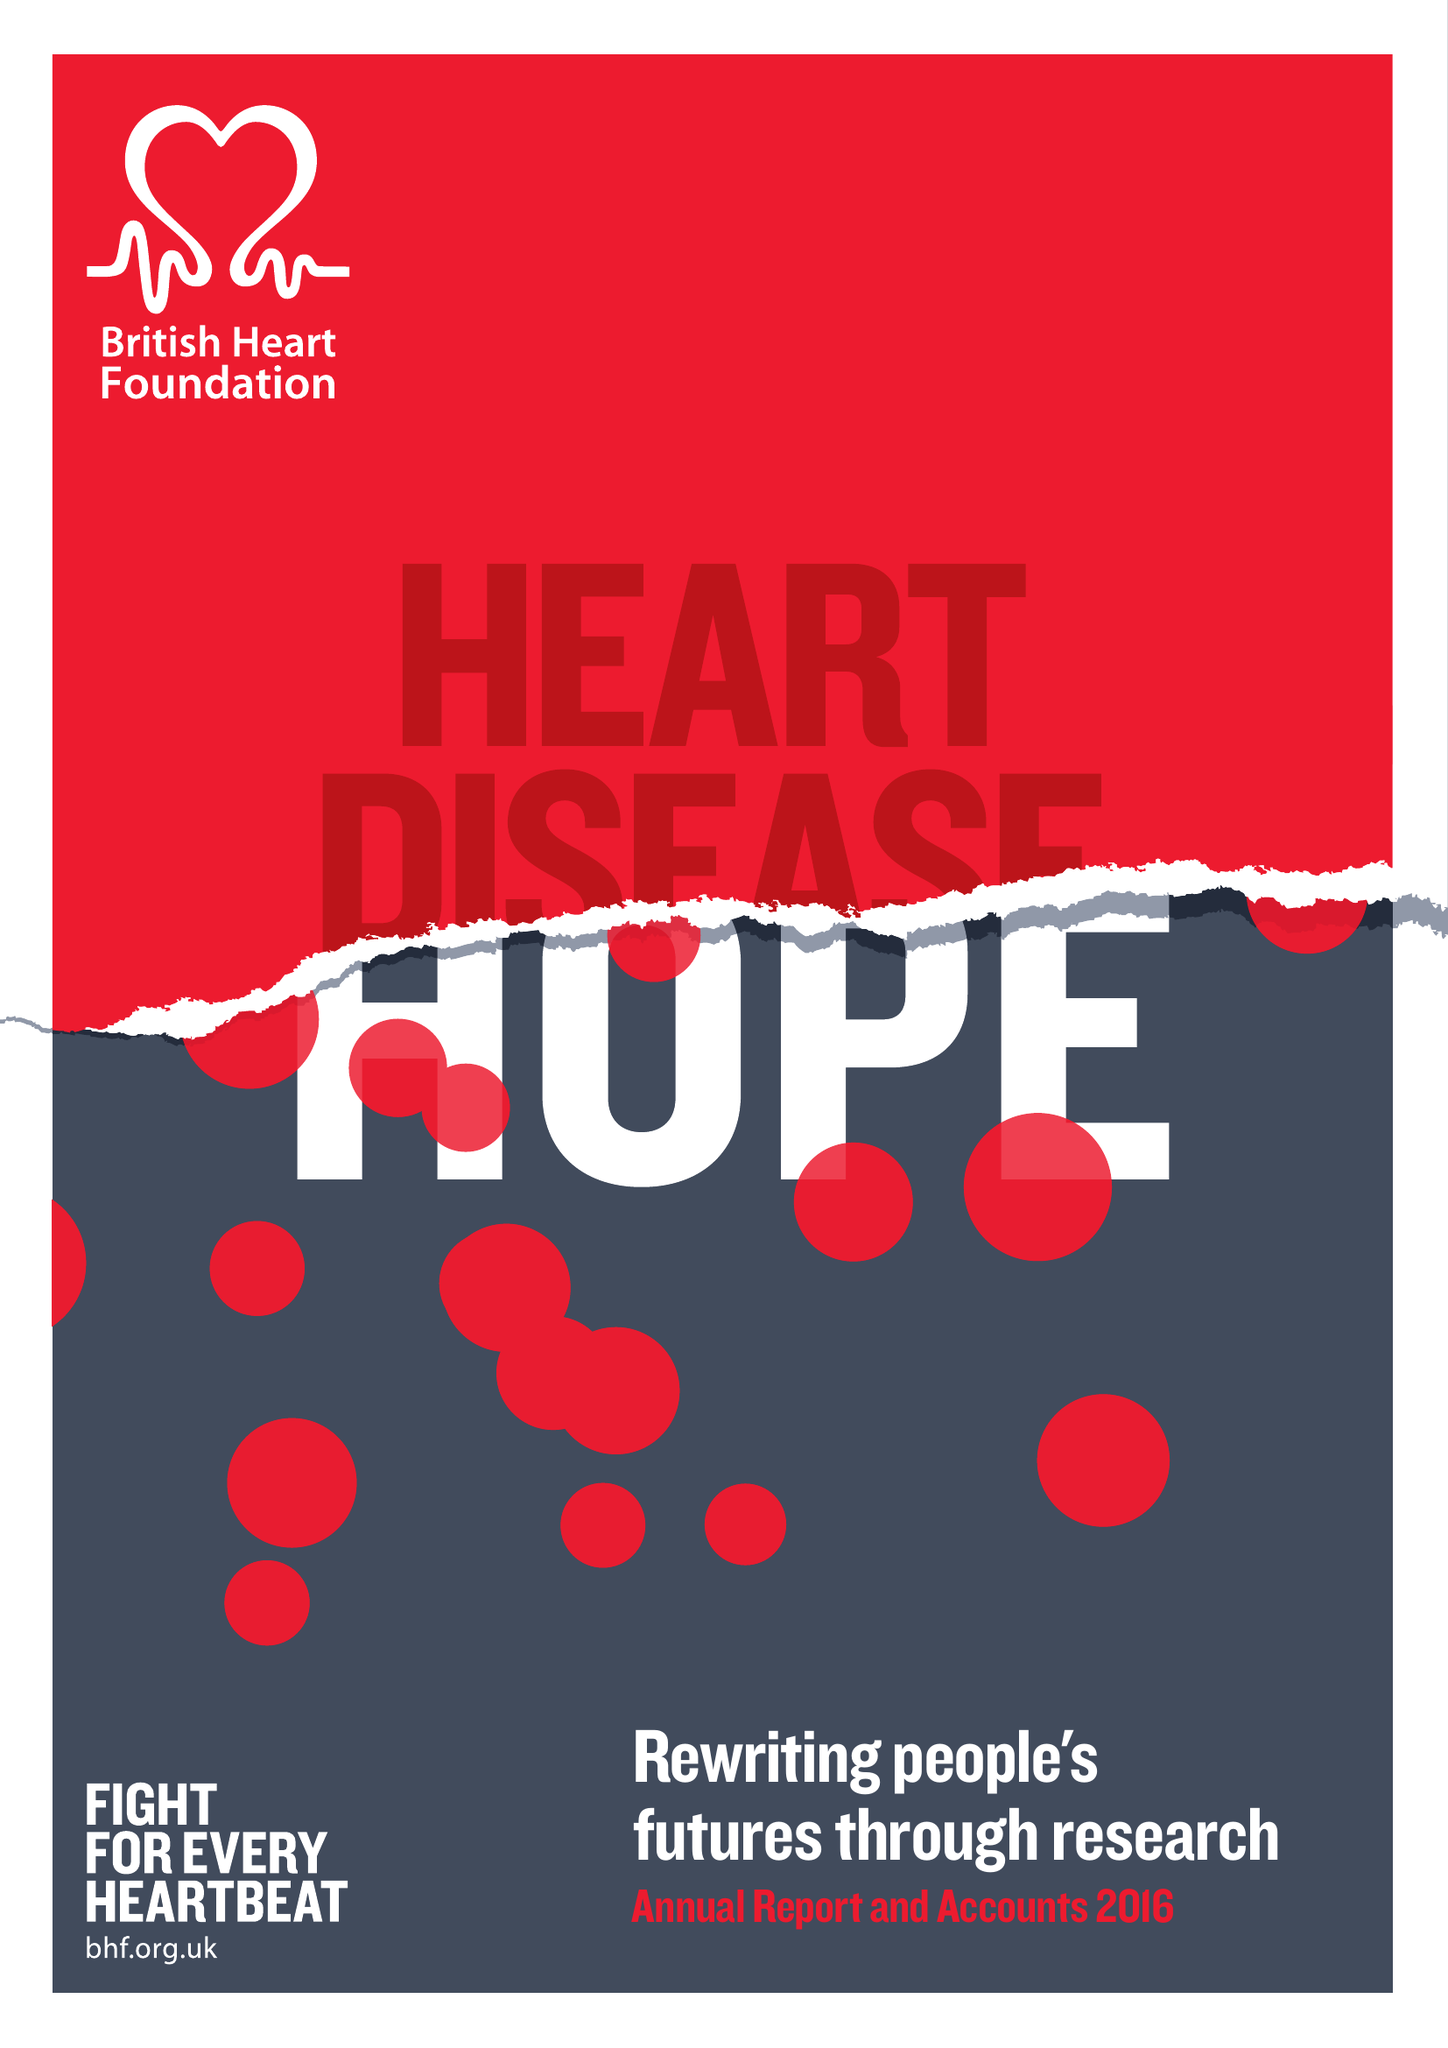What is the value for the income_annually_in_british_pounds?
Answer the question using a single word or phrase. 301500000.00 